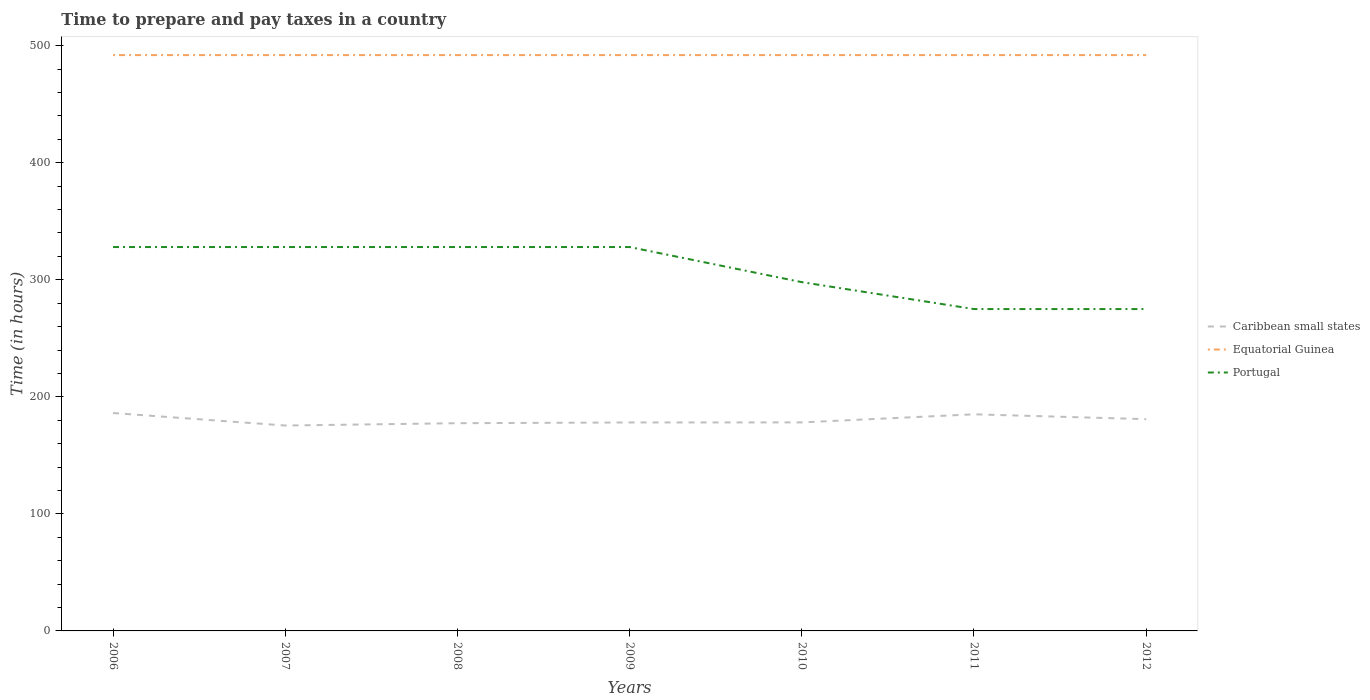Does the line corresponding to Caribbean small states intersect with the line corresponding to Portugal?
Your answer should be compact. No. Is the number of lines equal to the number of legend labels?
Your response must be concise. Yes. Across all years, what is the maximum number of hours required to prepare and pay taxes in Caribbean small states?
Your answer should be compact. 175.5. What is the total number of hours required to prepare and pay taxes in Equatorial Guinea in the graph?
Keep it short and to the point. 0. What is the difference between the highest and the second highest number of hours required to prepare and pay taxes in Portugal?
Offer a terse response. 53. What is the difference between the highest and the lowest number of hours required to prepare and pay taxes in Caribbean small states?
Keep it short and to the point. 3. How many years are there in the graph?
Your answer should be compact. 7. Are the values on the major ticks of Y-axis written in scientific E-notation?
Provide a succinct answer. No. Where does the legend appear in the graph?
Your answer should be compact. Center right. How many legend labels are there?
Keep it short and to the point. 3. How are the legend labels stacked?
Your response must be concise. Vertical. What is the title of the graph?
Your answer should be compact. Time to prepare and pay taxes in a country. Does "Cameroon" appear as one of the legend labels in the graph?
Your response must be concise. No. What is the label or title of the Y-axis?
Offer a very short reply. Time (in hours). What is the Time (in hours) of Caribbean small states in 2006?
Provide a succinct answer. 186.18. What is the Time (in hours) of Equatorial Guinea in 2006?
Your answer should be compact. 492. What is the Time (in hours) of Portugal in 2006?
Provide a short and direct response. 328. What is the Time (in hours) of Caribbean small states in 2007?
Make the answer very short. 175.5. What is the Time (in hours) of Equatorial Guinea in 2007?
Provide a succinct answer. 492. What is the Time (in hours) in Portugal in 2007?
Give a very brief answer. 328. What is the Time (in hours) in Caribbean small states in 2008?
Provide a succinct answer. 177.48. What is the Time (in hours) in Equatorial Guinea in 2008?
Offer a very short reply. 492. What is the Time (in hours) in Portugal in 2008?
Give a very brief answer. 328. What is the Time (in hours) of Caribbean small states in 2009?
Ensure brevity in your answer.  178.11. What is the Time (in hours) of Equatorial Guinea in 2009?
Offer a terse response. 492. What is the Time (in hours) of Portugal in 2009?
Your answer should be very brief. 328. What is the Time (in hours) in Caribbean small states in 2010?
Give a very brief answer. 178.17. What is the Time (in hours) of Equatorial Guinea in 2010?
Offer a terse response. 492. What is the Time (in hours) of Portugal in 2010?
Offer a very short reply. 298. What is the Time (in hours) in Caribbean small states in 2011?
Keep it short and to the point. 185.08. What is the Time (in hours) in Equatorial Guinea in 2011?
Your answer should be very brief. 492. What is the Time (in hours) in Portugal in 2011?
Provide a succinct answer. 275. What is the Time (in hours) in Caribbean small states in 2012?
Your response must be concise. 180.92. What is the Time (in hours) of Equatorial Guinea in 2012?
Your response must be concise. 492. What is the Time (in hours) of Portugal in 2012?
Provide a succinct answer. 275. Across all years, what is the maximum Time (in hours) in Caribbean small states?
Offer a very short reply. 186.18. Across all years, what is the maximum Time (in hours) of Equatorial Guinea?
Make the answer very short. 492. Across all years, what is the maximum Time (in hours) in Portugal?
Keep it short and to the point. 328. Across all years, what is the minimum Time (in hours) in Caribbean small states?
Offer a terse response. 175.5. Across all years, what is the minimum Time (in hours) in Equatorial Guinea?
Make the answer very short. 492. Across all years, what is the minimum Time (in hours) of Portugal?
Your response must be concise. 275. What is the total Time (in hours) of Caribbean small states in the graph?
Your answer should be compact. 1261.44. What is the total Time (in hours) in Equatorial Guinea in the graph?
Provide a succinct answer. 3444. What is the total Time (in hours) of Portugal in the graph?
Your answer should be very brief. 2160. What is the difference between the Time (in hours) in Caribbean small states in 2006 and that in 2007?
Provide a short and direct response. 10.68. What is the difference between the Time (in hours) of Portugal in 2006 and that in 2007?
Your answer should be compact. 0. What is the difference between the Time (in hours) of Caribbean small states in 2006 and that in 2008?
Keep it short and to the point. 8.7. What is the difference between the Time (in hours) of Caribbean small states in 2006 and that in 2009?
Provide a short and direct response. 8.07. What is the difference between the Time (in hours) in Equatorial Guinea in 2006 and that in 2009?
Give a very brief answer. 0. What is the difference between the Time (in hours) in Portugal in 2006 and that in 2009?
Make the answer very short. 0. What is the difference between the Time (in hours) of Caribbean small states in 2006 and that in 2010?
Ensure brevity in your answer.  8.02. What is the difference between the Time (in hours) in Portugal in 2006 and that in 2010?
Provide a succinct answer. 30. What is the difference between the Time (in hours) of Caribbean small states in 2006 and that in 2011?
Your answer should be very brief. 1.1. What is the difference between the Time (in hours) in Caribbean small states in 2006 and that in 2012?
Keep it short and to the point. 5.26. What is the difference between the Time (in hours) in Equatorial Guinea in 2006 and that in 2012?
Make the answer very short. 0. What is the difference between the Time (in hours) of Caribbean small states in 2007 and that in 2008?
Keep it short and to the point. -1.98. What is the difference between the Time (in hours) of Equatorial Guinea in 2007 and that in 2008?
Offer a terse response. 0. What is the difference between the Time (in hours) of Caribbean small states in 2007 and that in 2009?
Offer a terse response. -2.61. What is the difference between the Time (in hours) of Equatorial Guinea in 2007 and that in 2009?
Your answer should be very brief. 0. What is the difference between the Time (in hours) of Portugal in 2007 and that in 2009?
Ensure brevity in your answer.  0. What is the difference between the Time (in hours) of Caribbean small states in 2007 and that in 2010?
Ensure brevity in your answer.  -2.67. What is the difference between the Time (in hours) of Equatorial Guinea in 2007 and that in 2010?
Keep it short and to the point. 0. What is the difference between the Time (in hours) of Caribbean small states in 2007 and that in 2011?
Your answer should be very brief. -9.58. What is the difference between the Time (in hours) of Caribbean small states in 2007 and that in 2012?
Your answer should be compact. -5.42. What is the difference between the Time (in hours) in Equatorial Guinea in 2007 and that in 2012?
Give a very brief answer. 0. What is the difference between the Time (in hours) of Portugal in 2007 and that in 2012?
Provide a succinct answer. 53. What is the difference between the Time (in hours) in Caribbean small states in 2008 and that in 2009?
Give a very brief answer. -0.62. What is the difference between the Time (in hours) of Caribbean small states in 2008 and that in 2010?
Keep it short and to the point. -0.68. What is the difference between the Time (in hours) in Equatorial Guinea in 2008 and that in 2010?
Keep it short and to the point. 0. What is the difference between the Time (in hours) of Portugal in 2008 and that in 2010?
Offer a terse response. 30. What is the difference between the Time (in hours) of Caribbean small states in 2008 and that in 2011?
Give a very brief answer. -7.59. What is the difference between the Time (in hours) of Equatorial Guinea in 2008 and that in 2011?
Your response must be concise. 0. What is the difference between the Time (in hours) in Portugal in 2008 and that in 2011?
Provide a succinct answer. 53. What is the difference between the Time (in hours) in Caribbean small states in 2008 and that in 2012?
Make the answer very short. -3.44. What is the difference between the Time (in hours) in Caribbean small states in 2009 and that in 2010?
Offer a terse response. -0.06. What is the difference between the Time (in hours) in Caribbean small states in 2009 and that in 2011?
Your answer should be very brief. -6.97. What is the difference between the Time (in hours) of Caribbean small states in 2009 and that in 2012?
Provide a short and direct response. -2.81. What is the difference between the Time (in hours) of Equatorial Guinea in 2009 and that in 2012?
Keep it short and to the point. 0. What is the difference between the Time (in hours) in Caribbean small states in 2010 and that in 2011?
Give a very brief answer. -6.91. What is the difference between the Time (in hours) in Equatorial Guinea in 2010 and that in 2011?
Provide a short and direct response. 0. What is the difference between the Time (in hours) in Portugal in 2010 and that in 2011?
Keep it short and to the point. 23. What is the difference between the Time (in hours) in Caribbean small states in 2010 and that in 2012?
Your response must be concise. -2.76. What is the difference between the Time (in hours) in Equatorial Guinea in 2010 and that in 2012?
Keep it short and to the point. 0. What is the difference between the Time (in hours) of Portugal in 2010 and that in 2012?
Provide a succinct answer. 23. What is the difference between the Time (in hours) of Caribbean small states in 2011 and that in 2012?
Ensure brevity in your answer.  4.15. What is the difference between the Time (in hours) of Portugal in 2011 and that in 2012?
Make the answer very short. 0. What is the difference between the Time (in hours) of Caribbean small states in 2006 and the Time (in hours) of Equatorial Guinea in 2007?
Make the answer very short. -305.82. What is the difference between the Time (in hours) in Caribbean small states in 2006 and the Time (in hours) in Portugal in 2007?
Offer a very short reply. -141.82. What is the difference between the Time (in hours) in Equatorial Guinea in 2006 and the Time (in hours) in Portugal in 2007?
Provide a short and direct response. 164. What is the difference between the Time (in hours) in Caribbean small states in 2006 and the Time (in hours) in Equatorial Guinea in 2008?
Make the answer very short. -305.82. What is the difference between the Time (in hours) in Caribbean small states in 2006 and the Time (in hours) in Portugal in 2008?
Provide a short and direct response. -141.82. What is the difference between the Time (in hours) in Equatorial Guinea in 2006 and the Time (in hours) in Portugal in 2008?
Give a very brief answer. 164. What is the difference between the Time (in hours) in Caribbean small states in 2006 and the Time (in hours) in Equatorial Guinea in 2009?
Your answer should be very brief. -305.82. What is the difference between the Time (in hours) of Caribbean small states in 2006 and the Time (in hours) of Portugal in 2009?
Keep it short and to the point. -141.82. What is the difference between the Time (in hours) of Equatorial Guinea in 2006 and the Time (in hours) of Portugal in 2009?
Provide a short and direct response. 164. What is the difference between the Time (in hours) in Caribbean small states in 2006 and the Time (in hours) in Equatorial Guinea in 2010?
Keep it short and to the point. -305.82. What is the difference between the Time (in hours) in Caribbean small states in 2006 and the Time (in hours) in Portugal in 2010?
Offer a terse response. -111.82. What is the difference between the Time (in hours) of Equatorial Guinea in 2006 and the Time (in hours) of Portugal in 2010?
Give a very brief answer. 194. What is the difference between the Time (in hours) in Caribbean small states in 2006 and the Time (in hours) in Equatorial Guinea in 2011?
Provide a short and direct response. -305.82. What is the difference between the Time (in hours) of Caribbean small states in 2006 and the Time (in hours) of Portugal in 2011?
Provide a succinct answer. -88.82. What is the difference between the Time (in hours) in Equatorial Guinea in 2006 and the Time (in hours) in Portugal in 2011?
Provide a short and direct response. 217. What is the difference between the Time (in hours) of Caribbean small states in 2006 and the Time (in hours) of Equatorial Guinea in 2012?
Provide a short and direct response. -305.82. What is the difference between the Time (in hours) in Caribbean small states in 2006 and the Time (in hours) in Portugal in 2012?
Ensure brevity in your answer.  -88.82. What is the difference between the Time (in hours) in Equatorial Guinea in 2006 and the Time (in hours) in Portugal in 2012?
Ensure brevity in your answer.  217. What is the difference between the Time (in hours) in Caribbean small states in 2007 and the Time (in hours) in Equatorial Guinea in 2008?
Make the answer very short. -316.5. What is the difference between the Time (in hours) of Caribbean small states in 2007 and the Time (in hours) of Portugal in 2008?
Keep it short and to the point. -152.5. What is the difference between the Time (in hours) in Equatorial Guinea in 2007 and the Time (in hours) in Portugal in 2008?
Offer a terse response. 164. What is the difference between the Time (in hours) in Caribbean small states in 2007 and the Time (in hours) in Equatorial Guinea in 2009?
Your answer should be very brief. -316.5. What is the difference between the Time (in hours) in Caribbean small states in 2007 and the Time (in hours) in Portugal in 2009?
Ensure brevity in your answer.  -152.5. What is the difference between the Time (in hours) in Equatorial Guinea in 2007 and the Time (in hours) in Portugal in 2009?
Your answer should be compact. 164. What is the difference between the Time (in hours) of Caribbean small states in 2007 and the Time (in hours) of Equatorial Guinea in 2010?
Make the answer very short. -316.5. What is the difference between the Time (in hours) in Caribbean small states in 2007 and the Time (in hours) in Portugal in 2010?
Provide a short and direct response. -122.5. What is the difference between the Time (in hours) of Equatorial Guinea in 2007 and the Time (in hours) of Portugal in 2010?
Keep it short and to the point. 194. What is the difference between the Time (in hours) in Caribbean small states in 2007 and the Time (in hours) in Equatorial Guinea in 2011?
Your response must be concise. -316.5. What is the difference between the Time (in hours) of Caribbean small states in 2007 and the Time (in hours) of Portugal in 2011?
Make the answer very short. -99.5. What is the difference between the Time (in hours) in Equatorial Guinea in 2007 and the Time (in hours) in Portugal in 2011?
Offer a very short reply. 217. What is the difference between the Time (in hours) of Caribbean small states in 2007 and the Time (in hours) of Equatorial Guinea in 2012?
Give a very brief answer. -316.5. What is the difference between the Time (in hours) in Caribbean small states in 2007 and the Time (in hours) in Portugal in 2012?
Offer a very short reply. -99.5. What is the difference between the Time (in hours) in Equatorial Guinea in 2007 and the Time (in hours) in Portugal in 2012?
Offer a very short reply. 217. What is the difference between the Time (in hours) of Caribbean small states in 2008 and the Time (in hours) of Equatorial Guinea in 2009?
Give a very brief answer. -314.52. What is the difference between the Time (in hours) of Caribbean small states in 2008 and the Time (in hours) of Portugal in 2009?
Keep it short and to the point. -150.52. What is the difference between the Time (in hours) of Equatorial Guinea in 2008 and the Time (in hours) of Portugal in 2009?
Offer a terse response. 164. What is the difference between the Time (in hours) of Caribbean small states in 2008 and the Time (in hours) of Equatorial Guinea in 2010?
Offer a very short reply. -314.52. What is the difference between the Time (in hours) of Caribbean small states in 2008 and the Time (in hours) of Portugal in 2010?
Your answer should be very brief. -120.52. What is the difference between the Time (in hours) in Equatorial Guinea in 2008 and the Time (in hours) in Portugal in 2010?
Provide a short and direct response. 194. What is the difference between the Time (in hours) of Caribbean small states in 2008 and the Time (in hours) of Equatorial Guinea in 2011?
Keep it short and to the point. -314.52. What is the difference between the Time (in hours) of Caribbean small states in 2008 and the Time (in hours) of Portugal in 2011?
Keep it short and to the point. -97.52. What is the difference between the Time (in hours) in Equatorial Guinea in 2008 and the Time (in hours) in Portugal in 2011?
Give a very brief answer. 217. What is the difference between the Time (in hours) of Caribbean small states in 2008 and the Time (in hours) of Equatorial Guinea in 2012?
Give a very brief answer. -314.52. What is the difference between the Time (in hours) in Caribbean small states in 2008 and the Time (in hours) in Portugal in 2012?
Provide a succinct answer. -97.52. What is the difference between the Time (in hours) in Equatorial Guinea in 2008 and the Time (in hours) in Portugal in 2012?
Your answer should be very brief. 217. What is the difference between the Time (in hours) in Caribbean small states in 2009 and the Time (in hours) in Equatorial Guinea in 2010?
Your answer should be very brief. -313.89. What is the difference between the Time (in hours) in Caribbean small states in 2009 and the Time (in hours) in Portugal in 2010?
Offer a very short reply. -119.89. What is the difference between the Time (in hours) of Equatorial Guinea in 2009 and the Time (in hours) of Portugal in 2010?
Ensure brevity in your answer.  194. What is the difference between the Time (in hours) of Caribbean small states in 2009 and the Time (in hours) of Equatorial Guinea in 2011?
Your answer should be very brief. -313.89. What is the difference between the Time (in hours) of Caribbean small states in 2009 and the Time (in hours) of Portugal in 2011?
Your answer should be very brief. -96.89. What is the difference between the Time (in hours) of Equatorial Guinea in 2009 and the Time (in hours) of Portugal in 2011?
Offer a very short reply. 217. What is the difference between the Time (in hours) of Caribbean small states in 2009 and the Time (in hours) of Equatorial Guinea in 2012?
Your answer should be compact. -313.89. What is the difference between the Time (in hours) in Caribbean small states in 2009 and the Time (in hours) in Portugal in 2012?
Your response must be concise. -96.89. What is the difference between the Time (in hours) of Equatorial Guinea in 2009 and the Time (in hours) of Portugal in 2012?
Make the answer very short. 217. What is the difference between the Time (in hours) of Caribbean small states in 2010 and the Time (in hours) of Equatorial Guinea in 2011?
Make the answer very short. -313.83. What is the difference between the Time (in hours) in Caribbean small states in 2010 and the Time (in hours) in Portugal in 2011?
Your answer should be very brief. -96.83. What is the difference between the Time (in hours) in Equatorial Guinea in 2010 and the Time (in hours) in Portugal in 2011?
Offer a terse response. 217. What is the difference between the Time (in hours) of Caribbean small states in 2010 and the Time (in hours) of Equatorial Guinea in 2012?
Provide a short and direct response. -313.83. What is the difference between the Time (in hours) in Caribbean small states in 2010 and the Time (in hours) in Portugal in 2012?
Provide a short and direct response. -96.83. What is the difference between the Time (in hours) of Equatorial Guinea in 2010 and the Time (in hours) of Portugal in 2012?
Ensure brevity in your answer.  217. What is the difference between the Time (in hours) of Caribbean small states in 2011 and the Time (in hours) of Equatorial Guinea in 2012?
Your answer should be compact. -306.92. What is the difference between the Time (in hours) of Caribbean small states in 2011 and the Time (in hours) of Portugal in 2012?
Your response must be concise. -89.92. What is the difference between the Time (in hours) in Equatorial Guinea in 2011 and the Time (in hours) in Portugal in 2012?
Your answer should be compact. 217. What is the average Time (in hours) of Caribbean small states per year?
Your answer should be compact. 180.21. What is the average Time (in hours) in Equatorial Guinea per year?
Give a very brief answer. 492. What is the average Time (in hours) in Portugal per year?
Offer a terse response. 308.57. In the year 2006, what is the difference between the Time (in hours) of Caribbean small states and Time (in hours) of Equatorial Guinea?
Your response must be concise. -305.82. In the year 2006, what is the difference between the Time (in hours) in Caribbean small states and Time (in hours) in Portugal?
Your response must be concise. -141.82. In the year 2006, what is the difference between the Time (in hours) of Equatorial Guinea and Time (in hours) of Portugal?
Offer a terse response. 164. In the year 2007, what is the difference between the Time (in hours) in Caribbean small states and Time (in hours) in Equatorial Guinea?
Give a very brief answer. -316.5. In the year 2007, what is the difference between the Time (in hours) of Caribbean small states and Time (in hours) of Portugal?
Ensure brevity in your answer.  -152.5. In the year 2007, what is the difference between the Time (in hours) of Equatorial Guinea and Time (in hours) of Portugal?
Your response must be concise. 164. In the year 2008, what is the difference between the Time (in hours) of Caribbean small states and Time (in hours) of Equatorial Guinea?
Your response must be concise. -314.52. In the year 2008, what is the difference between the Time (in hours) of Caribbean small states and Time (in hours) of Portugal?
Your answer should be very brief. -150.52. In the year 2008, what is the difference between the Time (in hours) of Equatorial Guinea and Time (in hours) of Portugal?
Your answer should be compact. 164. In the year 2009, what is the difference between the Time (in hours) of Caribbean small states and Time (in hours) of Equatorial Guinea?
Your answer should be very brief. -313.89. In the year 2009, what is the difference between the Time (in hours) in Caribbean small states and Time (in hours) in Portugal?
Give a very brief answer. -149.89. In the year 2009, what is the difference between the Time (in hours) of Equatorial Guinea and Time (in hours) of Portugal?
Provide a short and direct response. 164. In the year 2010, what is the difference between the Time (in hours) of Caribbean small states and Time (in hours) of Equatorial Guinea?
Provide a short and direct response. -313.83. In the year 2010, what is the difference between the Time (in hours) of Caribbean small states and Time (in hours) of Portugal?
Offer a terse response. -119.83. In the year 2010, what is the difference between the Time (in hours) in Equatorial Guinea and Time (in hours) in Portugal?
Make the answer very short. 194. In the year 2011, what is the difference between the Time (in hours) of Caribbean small states and Time (in hours) of Equatorial Guinea?
Your response must be concise. -306.92. In the year 2011, what is the difference between the Time (in hours) in Caribbean small states and Time (in hours) in Portugal?
Your response must be concise. -89.92. In the year 2011, what is the difference between the Time (in hours) of Equatorial Guinea and Time (in hours) of Portugal?
Offer a very short reply. 217. In the year 2012, what is the difference between the Time (in hours) in Caribbean small states and Time (in hours) in Equatorial Guinea?
Your answer should be compact. -311.08. In the year 2012, what is the difference between the Time (in hours) in Caribbean small states and Time (in hours) in Portugal?
Provide a succinct answer. -94.08. In the year 2012, what is the difference between the Time (in hours) of Equatorial Guinea and Time (in hours) of Portugal?
Provide a succinct answer. 217. What is the ratio of the Time (in hours) of Caribbean small states in 2006 to that in 2007?
Your answer should be very brief. 1.06. What is the ratio of the Time (in hours) in Equatorial Guinea in 2006 to that in 2007?
Your response must be concise. 1. What is the ratio of the Time (in hours) in Portugal in 2006 to that in 2007?
Provide a short and direct response. 1. What is the ratio of the Time (in hours) of Caribbean small states in 2006 to that in 2008?
Offer a very short reply. 1.05. What is the ratio of the Time (in hours) in Equatorial Guinea in 2006 to that in 2008?
Offer a terse response. 1. What is the ratio of the Time (in hours) in Portugal in 2006 to that in 2008?
Your answer should be very brief. 1. What is the ratio of the Time (in hours) in Caribbean small states in 2006 to that in 2009?
Provide a short and direct response. 1.05. What is the ratio of the Time (in hours) of Portugal in 2006 to that in 2009?
Keep it short and to the point. 1. What is the ratio of the Time (in hours) in Caribbean small states in 2006 to that in 2010?
Keep it short and to the point. 1.04. What is the ratio of the Time (in hours) in Portugal in 2006 to that in 2010?
Provide a short and direct response. 1.1. What is the ratio of the Time (in hours) in Caribbean small states in 2006 to that in 2011?
Provide a succinct answer. 1.01. What is the ratio of the Time (in hours) in Equatorial Guinea in 2006 to that in 2011?
Provide a succinct answer. 1. What is the ratio of the Time (in hours) of Portugal in 2006 to that in 2011?
Give a very brief answer. 1.19. What is the ratio of the Time (in hours) in Caribbean small states in 2006 to that in 2012?
Give a very brief answer. 1.03. What is the ratio of the Time (in hours) of Portugal in 2006 to that in 2012?
Provide a short and direct response. 1.19. What is the ratio of the Time (in hours) in Caribbean small states in 2007 to that in 2008?
Make the answer very short. 0.99. What is the ratio of the Time (in hours) in Portugal in 2007 to that in 2008?
Your answer should be very brief. 1. What is the ratio of the Time (in hours) in Caribbean small states in 2007 to that in 2009?
Offer a terse response. 0.99. What is the ratio of the Time (in hours) of Portugal in 2007 to that in 2010?
Your answer should be very brief. 1.1. What is the ratio of the Time (in hours) in Caribbean small states in 2007 to that in 2011?
Keep it short and to the point. 0.95. What is the ratio of the Time (in hours) of Equatorial Guinea in 2007 to that in 2011?
Provide a short and direct response. 1. What is the ratio of the Time (in hours) of Portugal in 2007 to that in 2011?
Provide a succinct answer. 1.19. What is the ratio of the Time (in hours) in Caribbean small states in 2007 to that in 2012?
Provide a short and direct response. 0.97. What is the ratio of the Time (in hours) in Portugal in 2007 to that in 2012?
Offer a very short reply. 1.19. What is the ratio of the Time (in hours) of Portugal in 2008 to that in 2009?
Your response must be concise. 1. What is the ratio of the Time (in hours) of Caribbean small states in 2008 to that in 2010?
Provide a short and direct response. 1. What is the ratio of the Time (in hours) of Portugal in 2008 to that in 2010?
Ensure brevity in your answer.  1.1. What is the ratio of the Time (in hours) of Caribbean small states in 2008 to that in 2011?
Provide a short and direct response. 0.96. What is the ratio of the Time (in hours) in Equatorial Guinea in 2008 to that in 2011?
Your answer should be compact. 1. What is the ratio of the Time (in hours) of Portugal in 2008 to that in 2011?
Your response must be concise. 1.19. What is the ratio of the Time (in hours) of Caribbean small states in 2008 to that in 2012?
Provide a short and direct response. 0.98. What is the ratio of the Time (in hours) of Equatorial Guinea in 2008 to that in 2012?
Provide a short and direct response. 1. What is the ratio of the Time (in hours) of Portugal in 2008 to that in 2012?
Ensure brevity in your answer.  1.19. What is the ratio of the Time (in hours) in Portugal in 2009 to that in 2010?
Ensure brevity in your answer.  1.1. What is the ratio of the Time (in hours) in Caribbean small states in 2009 to that in 2011?
Make the answer very short. 0.96. What is the ratio of the Time (in hours) of Portugal in 2009 to that in 2011?
Your answer should be compact. 1.19. What is the ratio of the Time (in hours) in Caribbean small states in 2009 to that in 2012?
Your answer should be very brief. 0.98. What is the ratio of the Time (in hours) of Portugal in 2009 to that in 2012?
Offer a very short reply. 1.19. What is the ratio of the Time (in hours) in Caribbean small states in 2010 to that in 2011?
Offer a very short reply. 0.96. What is the ratio of the Time (in hours) in Portugal in 2010 to that in 2011?
Give a very brief answer. 1.08. What is the ratio of the Time (in hours) in Caribbean small states in 2010 to that in 2012?
Make the answer very short. 0.98. What is the ratio of the Time (in hours) of Equatorial Guinea in 2010 to that in 2012?
Ensure brevity in your answer.  1. What is the ratio of the Time (in hours) of Portugal in 2010 to that in 2012?
Make the answer very short. 1.08. What is the ratio of the Time (in hours) in Caribbean small states in 2011 to that in 2012?
Your answer should be compact. 1.02. What is the ratio of the Time (in hours) of Equatorial Guinea in 2011 to that in 2012?
Offer a very short reply. 1. What is the difference between the highest and the second highest Time (in hours) of Caribbean small states?
Your answer should be very brief. 1.1. What is the difference between the highest and the second highest Time (in hours) in Equatorial Guinea?
Your answer should be compact. 0. What is the difference between the highest and the second highest Time (in hours) of Portugal?
Keep it short and to the point. 0. What is the difference between the highest and the lowest Time (in hours) in Caribbean small states?
Your answer should be compact. 10.68. What is the difference between the highest and the lowest Time (in hours) in Equatorial Guinea?
Your answer should be very brief. 0. What is the difference between the highest and the lowest Time (in hours) in Portugal?
Your response must be concise. 53. 